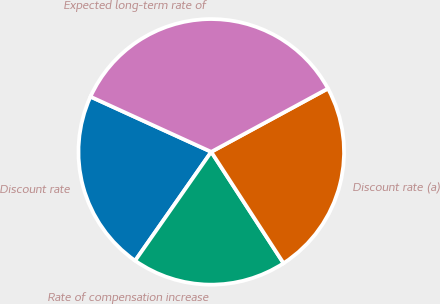Convert chart. <chart><loc_0><loc_0><loc_500><loc_500><pie_chart><fcel>Discount rate<fcel>Rate of compensation increase<fcel>Discount rate (a)<fcel>Expected long-term rate of<nl><fcel>22.11%<fcel>18.88%<fcel>23.75%<fcel>35.27%<nl></chart> 